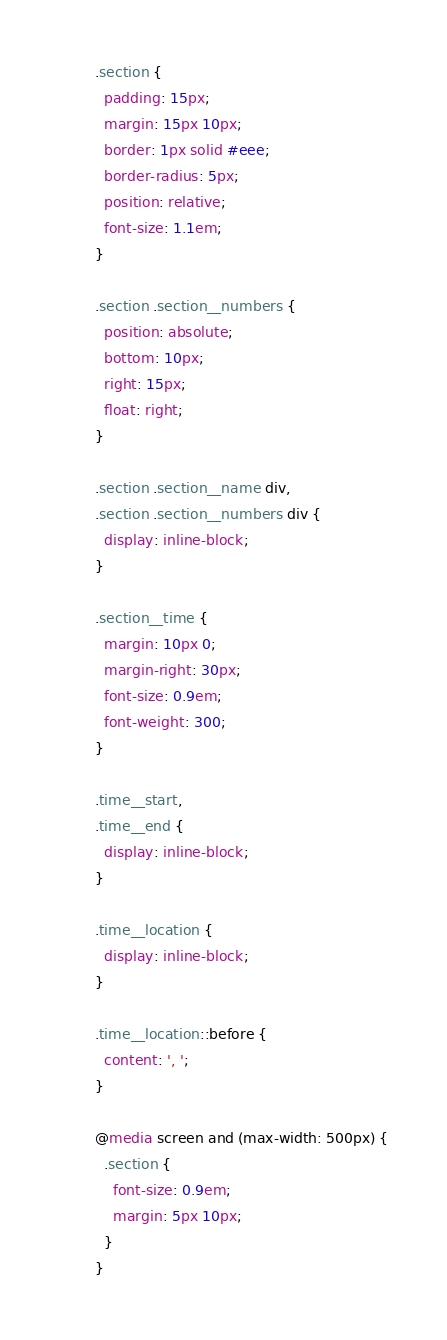Convert code to text. <code><loc_0><loc_0><loc_500><loc_500><_CSS_>.section {
  padding: 15px;
  margin: 15px 10px;
  border: 1px solid #eee;
  border-radius: 5px;
  position: relative;
  font-size: 1.1em;
}

.section .section__numbers {
  position: absolute;
  bottom: 10px;
  right: 15px;
  float: right;
}

.section .section__name div,
.section .section__numbers div {
  display: inline-block;
}

.section__time {
  margin: 10px 0;
  margin-right: 30px;
  font-size: 0.9em;
  font-weight: 300;
}

.time__start,
.time__end {
  display: inline-block;
}

.time__location {
  display: inline-block;
}

.time__location::before {
  content: ', ';
}

@media screen and (max-width: 500px) {
  .section {
    font-size: 0.9em;
    margin: 5px 10px;
  }
}
</code> 